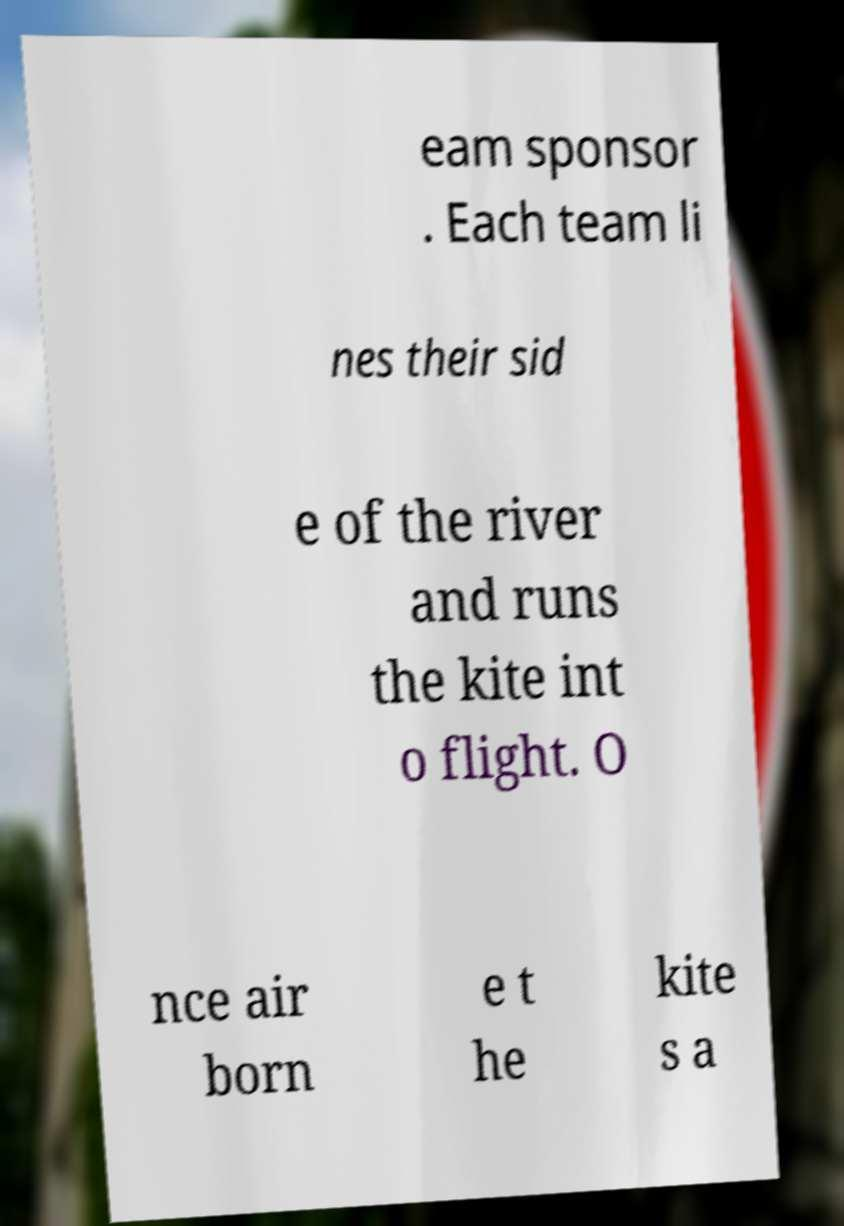Can you accurately transcribe the text from the provided image for me? eam sponsor . Each team li nes their sid e of the river and runs the kite int o flight. O nce air born e t he kite s a 